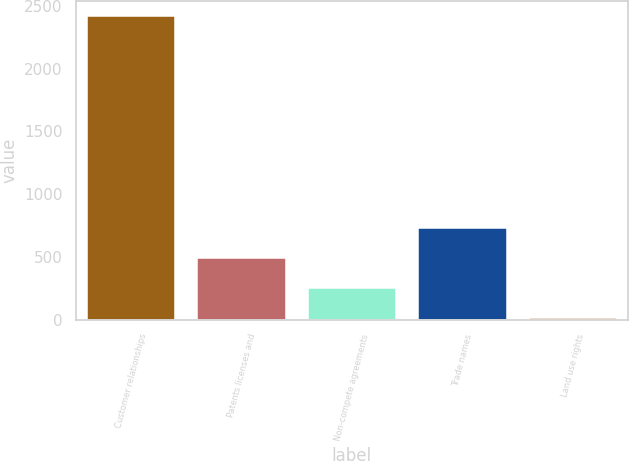Convert chart to OTSL. <chart><loc_0><loc_0><loc_500><loc_500><bar_chart><fcel>Customer relationships<fcel>Patents licenses and<fcel>Non-compete agreements<fcel>Trade names<fcel>Land use rights<nl><fcel>2420.1<fcel>490.9<fcel>249.75<fcel>732.05<fcel>8.6<nl></chart> 